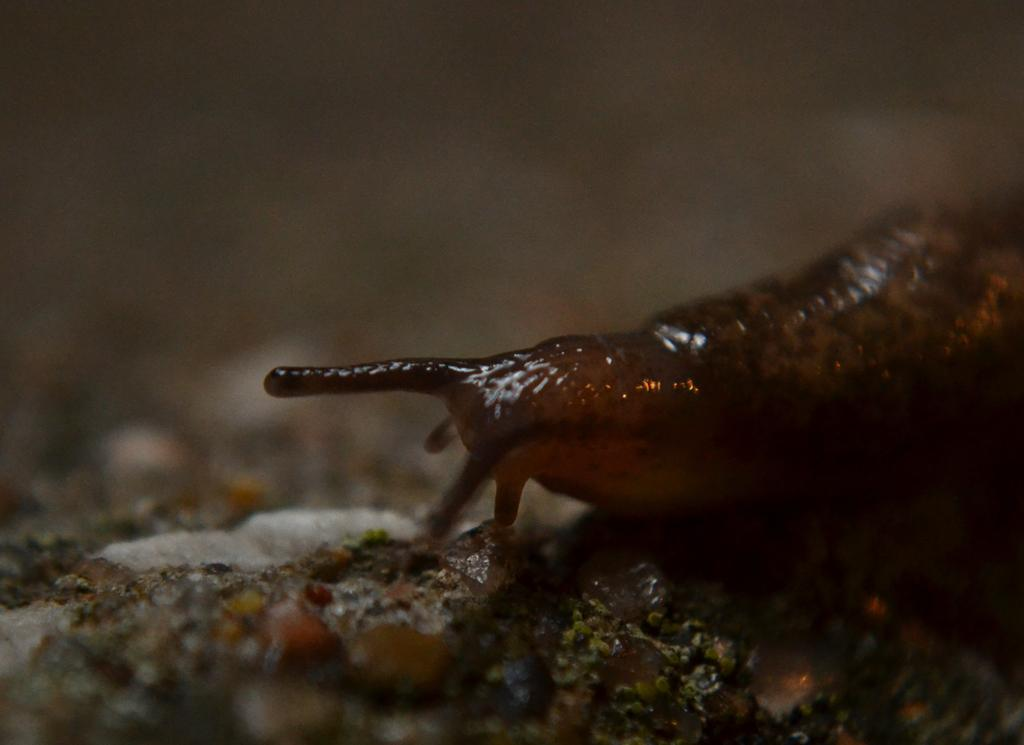What type of animal is in the foreground of the image? There is a snail on the surface in the foreground of the image. How many spiders are crawling on the snail in the image? There are no spiders present in the image; it only features a snail on the surface. What type of smoke can be seen coming from the snail in the image? There is no smoke present in the image, as it features a snail on the surface without any indication of smoke. 